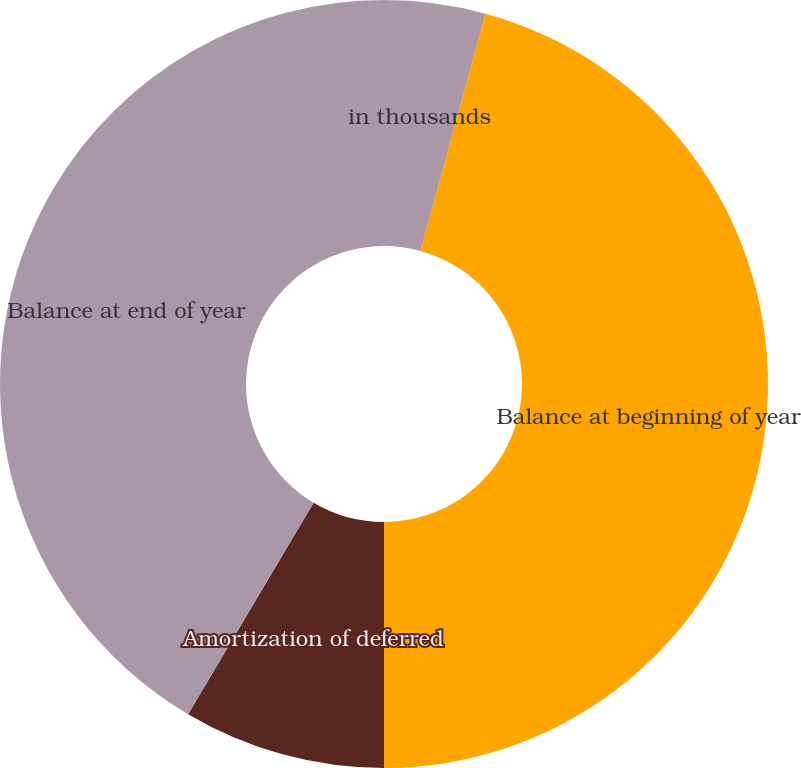Convert chart to OTSL. <chart><loc_0><loc_0><loc_500><loc_500><pie_chart><fcel>in thousands<fcel>Balance at beginning of year<fcel>Cash received and revenue<fcel>Amortization of deferred<fcel>Balance at end of year<nl><fcel>4.26%<fcel>45.74%<fcel>0.0%<fcel>8.52%<fcel>41.48%<nl></chart> 